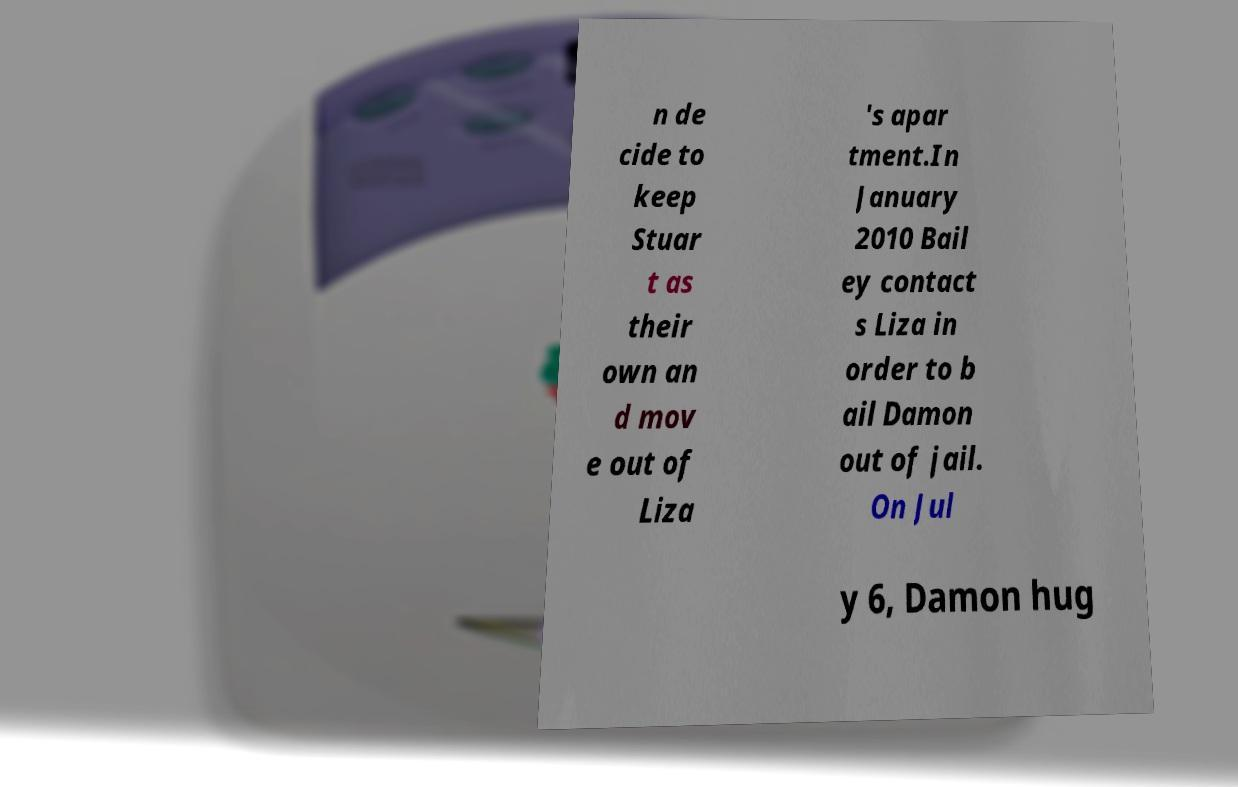What messages or text are displayed in this image? I need them in a readable, typed format. n de cide to keep Stuar t as their own an d mov e out of Liza 's apar tment.In January 2010 Bail ey contact s Liza in order to b ail Damon out of jail. On Jul y 6, Damon hug 